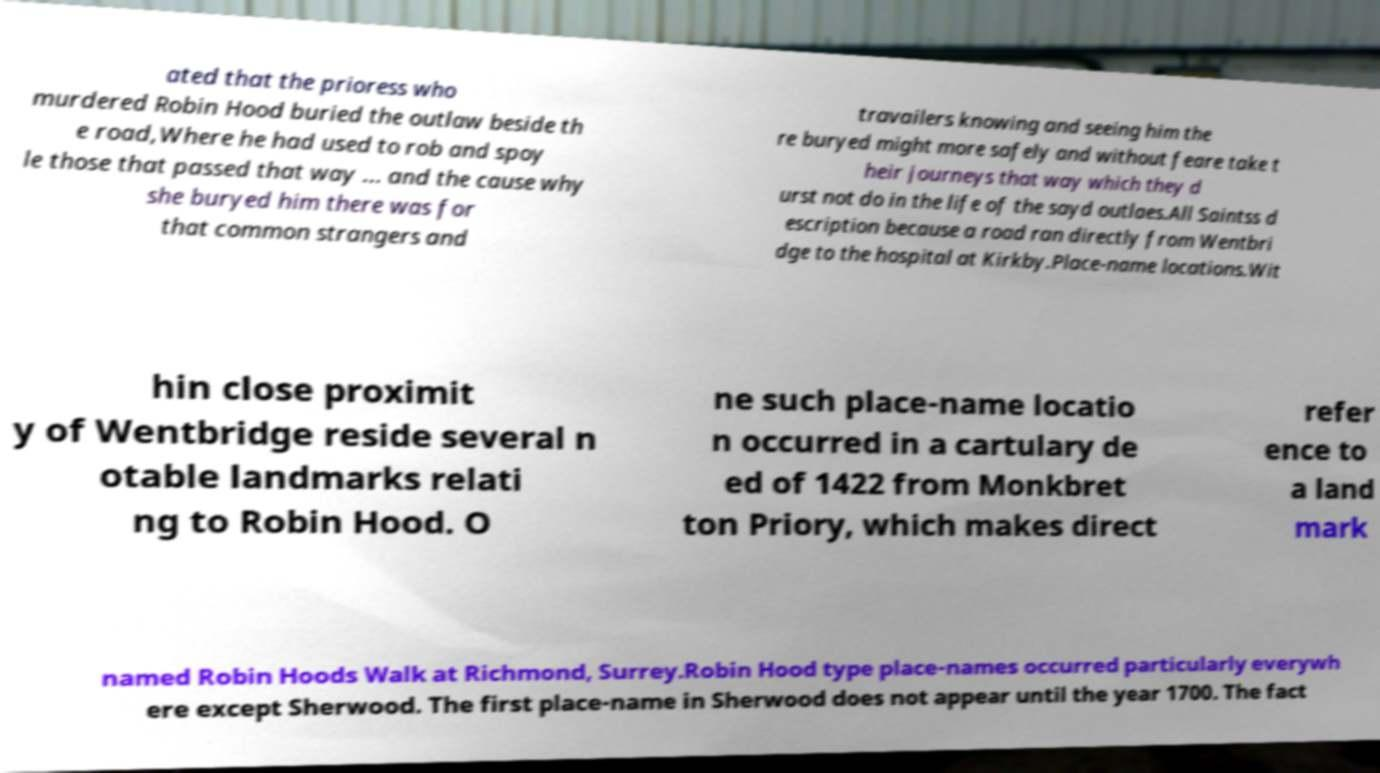Please identify and transcribe the text found in this image. ated that the prioress who murdered Robin Hood buried the outlaw beside th e road,Where he had used to rob and spoy le those that passed that way ... and the cause why she buryed him there was for that common strangers and travailers knowing and seeing him the re buryed might more safely and without feare take t heir journeys that way which they d urst not do in the life of the sayd outlaes.All Saintss d escription because a road ran directly from Wentbri dge to the hospital at Kirkby.Place-name locations.Wit hin close proximit y of Wentbridge reside several n otable landmarks relati ng to Robin Hood. O ne such place-name locatio n occurred in a cartulary de ed of 1422 from Monkbret ton Priory, which makes direct refer ence to a land mark named Robin Hoods Walk at Richmond, Surrey.Robin Hood type place-names occurred particularly everywh ere except Sherwood. The first place-name in Sherwood does not appear until the year 1700. The fact 